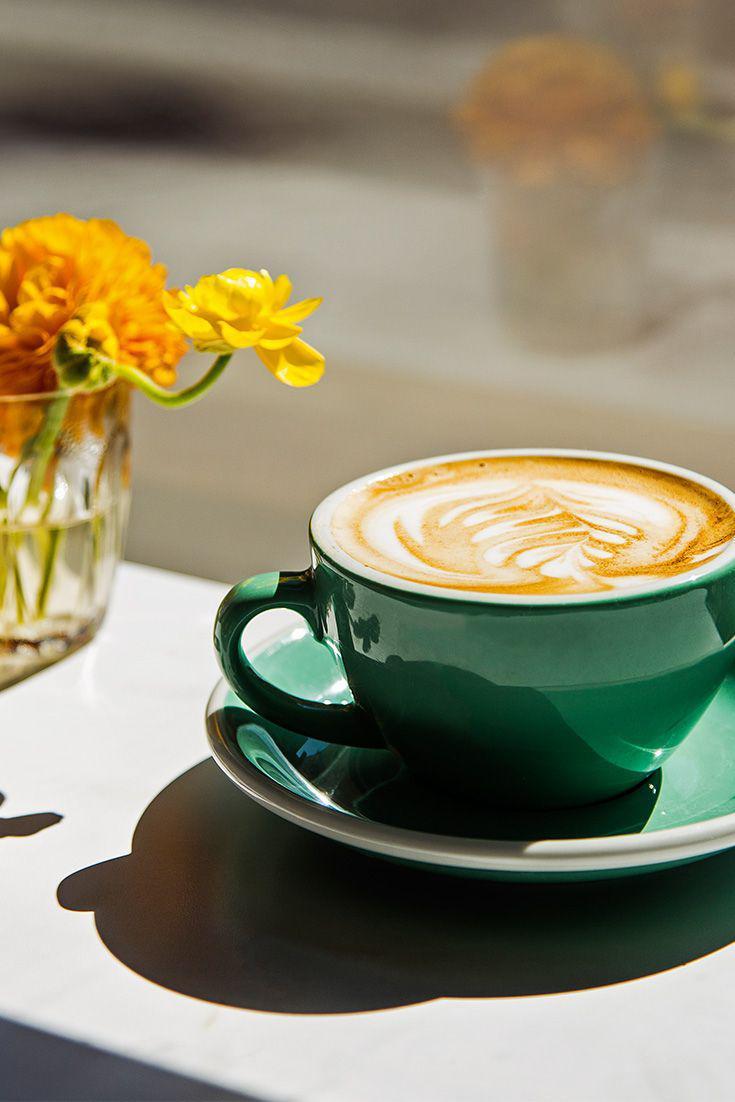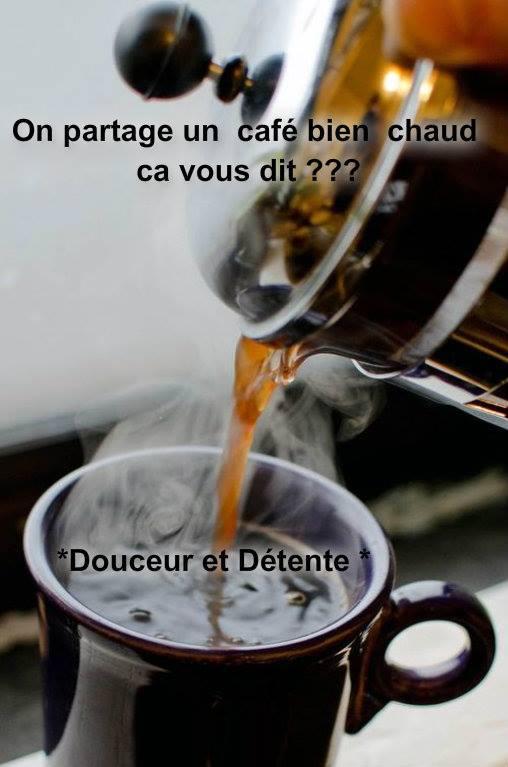The first image is the image on the left, the second image is the image on the right. Assess this claim about the two images: "An image shows two cups of beverage, with spoons nearby.". Correct or not? Answer yes or no. No. The first image is the image on the left, the second image is the image on the right. Examine the images to the left and right. Is the description "There are at least four cups of coffee." accurate? Answer yes or no. No. 